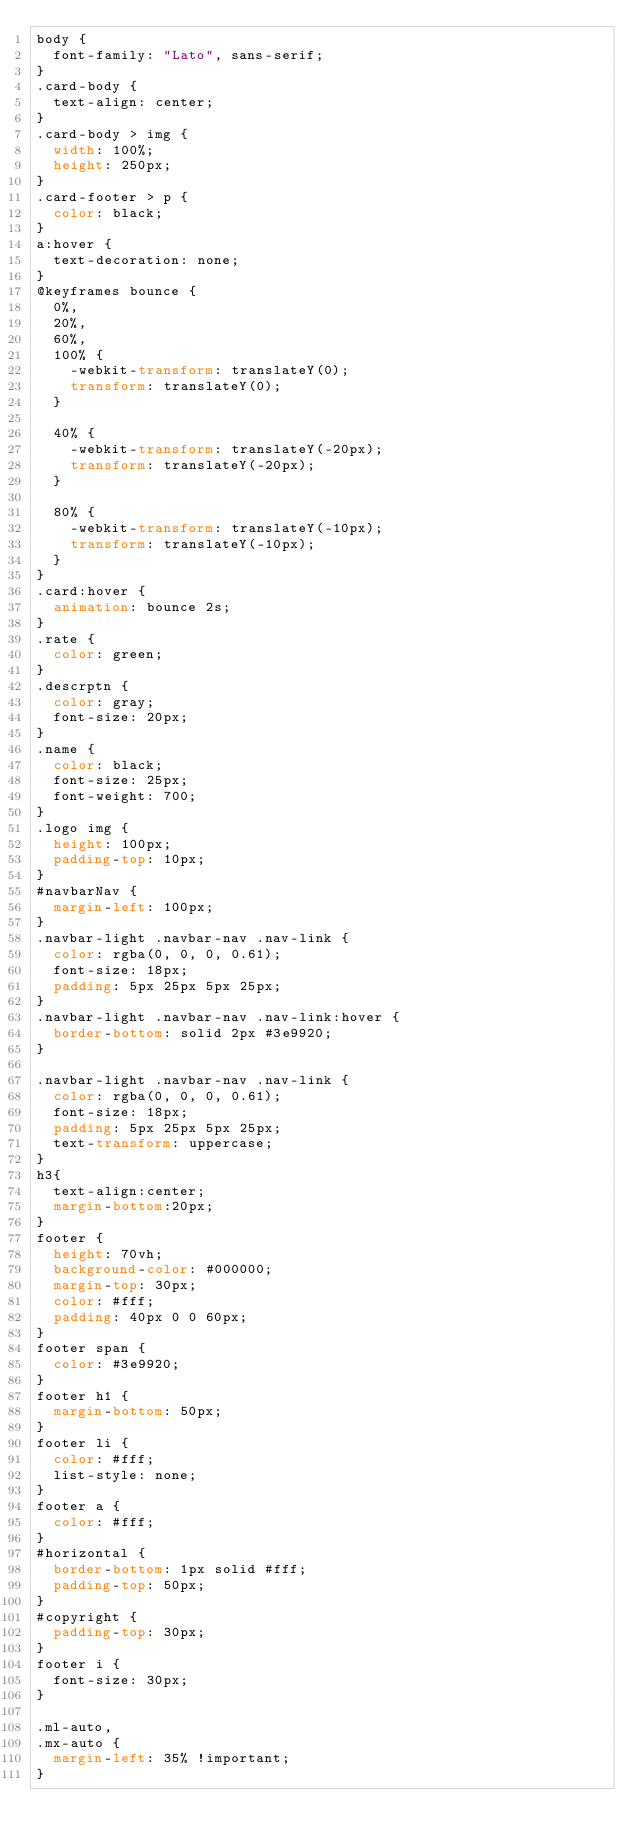Convert code to text. <code><loc_0><loc_0><loc_500><loc_500><_CSS_>body {
  font-family: "Lato", sans-serif;
}
.card-body {
  text-align: center;
}
.card-body > img {
  width: 100%;
  height: 250px;
}
.card-footer > p {
  color: black;
}
a:hover {
  text-decoration: none;
}
@keyframes bounce {
  0%,
  20%,
  60%,
  100% {
    -webkit-transform: translateY(0);
    transform: translateY(0);
  }

  40% {
    -webkit-transform: translateY(-20px);
    transform: translateY(-20px);
  }

  80% {
    -webkit-transform: translateY(-10px);
    transform: translateY(-10px);
  }
}
.card:hover {
  animation: bounce 2s;
}
.rate {
  color: green;
}
.descrptn {
  color: gray;
  font-size: 20px;
}
.name {
  color: black;
  font-size: 25px;
  font-weight: 700;
}
.logo img {
  height: 100px;
  padding-top: 10px;
}
#navbarNav {
  margin-left: 100px;
}
.navbar-light .navbar-nav .nav-link {
  color: rgba(0, 0, 0, 0.61);
  font-size: 18px;
  padding: 5px 25px 5px 25px;
}
.navbar-light .navbar-nav .nav-link:hover {
  border-bottom: solid 2px #3e9920;
}

.navbar-light .navbar-nav .nav-link {
  color: rgba(0, 0, 0, 0.61);
  font-size: 18px;
  padding: 5px 25px 5px 25px;
  text-transform: uppercase;
}
h3{
  text-align:center;
  margin-bottom:20px;
}
footer {
  height: 70vh;
  background-color: #000000;
  margin-top: 30px;
  color: #fff;
  padding: 40px 0 0 60px;
}
footer span {
  color: #3e9920;
}
footer h1 {
  margin-bottom: 50px;
}
footer li {
  color: #fff;
  list-style: none;
}
footer a {
  color: #fff;
}
#horizontal {
  border-bottom: 1px solid #fff;
  padding-top: 50px;
}
#copyright {
  padding-top: 30px;
}
footer i {
  font-size: 30px;
}

.ml-auto,
.mx-auto {
  margin-left: 35% !important;
}
</code> 